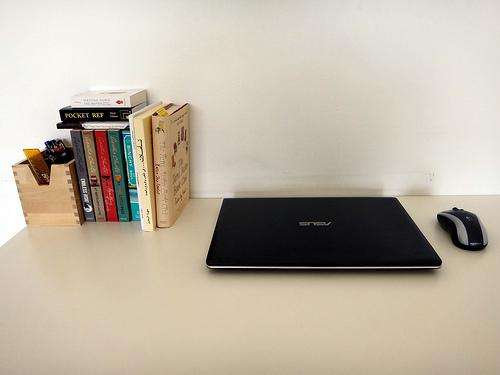Question: where is the laptop placed?
Choices:
A. On a lap.
B. On a desktop.
C. On the floor.
D. On a bed.
Answer with the letter. Answer: B Question: how is the laptop stored?
Choices:
A. It is in a bad.
B. It is on the desk.
C. It is closed.
D. It is put in a cabinet.
Answer with the letter. Answer: C Question: where are the books stacked?
Choices:
A. Desk.
B. Table.
C. Floor.
D. To the left of the laptop.
Answer with the letter. Answer: D Question: how many books are lined up on the desk?
Choices:
A. Seven.
B. Eight.
C. Five.
D. Twenty.
Answer with the letter. Answer: A Question: what type of computer mouse is shown?
Choices:
A. Wireless.
B. Wired.
C. White mouse.
D. Cordless.
Answer with the letter. Answer: D 